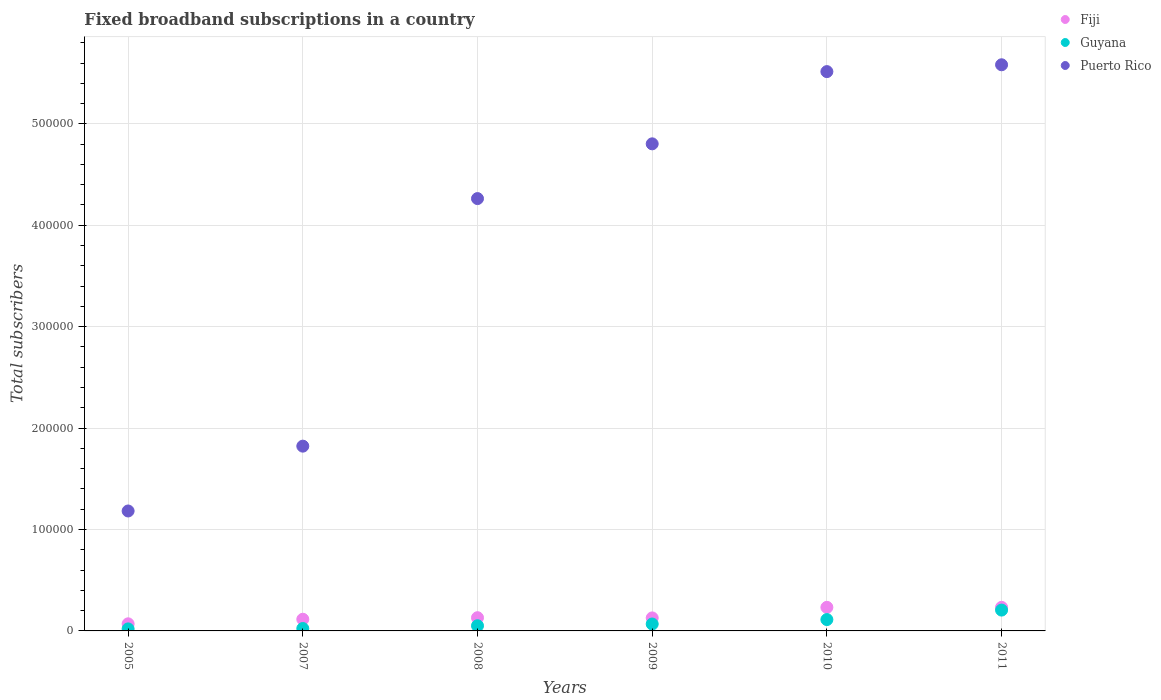How many different coloured dotlines are there?
Provide a short and direct response. 3. What is the number of broadband subscriptions in Fiji in 2005?
Offer a very short reply. 7000. Across all years, what is the maximum number of broadband subscriptions in Puerto Rico?
Your answer should be compact. 5.58e+05. Across all years, what is the minimum number of broadband subscriptions in Puerto Rico?
Your response must be concise. 1.18e+05. In which year was the number of broadband subscriptions in Puerto Rico minimum?
Make the answer very short. 2005. What is the total number of broadband subscriptions in Puerto Rico in the graph?
Provide a short and direct response. 2.32e+06. What is the difference between the number of broadband subscriptions in Guyana in 2008 and that in 2010?
Keep it short and to the point. -6109. What is the difference between the number of broadband subscriptions in Puerto Rico in 2009 and the number of broadband subscriptions in Guyana in 2010?
Make the answer very short. 4.69e+05. What is the average number of broadband subscriptions in Fiji per year?
Your answer should be very brief. 1.51e+04. In the year 2007, what is the difference between the number of broadband subscriptions in Guyana and number of broadband subscriptions in Fiji?
Your response must be concise. -9138. In how many years, is the number of broadband subscriptions in Guyana greater than 480000?
Offer a very short reply. 0. What is the ratio of the number of broadband subscriptions in Puerto Rico in 2008 to that in 2010?
Give a very brief answer. 0.77. Is the difference between the number of broadband subscriptions in Guyana in 2005 and 2008 greater than the difference between the number of broadband subscriptions in Fiji in 2005 and 2008?
Provide a succinct answer. Yes. What is the difference between the highest and the second highest number of broadband subscriptions in Puerto Rico?
Offer a terse response. 6731. What is the difference between the highest and the lowest number of broadband subscriptions in Guyana?
Make the answer very short. 1.85e+04. In how many years, is the number of broadband subscriptions in Puerto Rico greater than the average number of broadband subscriptions in Puerto Rico taken over all years?
Give a very brief answer. 4. Does the number of broadband subscriptions in Fiji monotonically increase over the years?
Keep it short and to the point. No. Is the number of broadband subscriptions in Puerto Rico strictly less than the number of broadband subscriptions in Fiji over the years?
Make the answer very short. No. What is the difference between two consecutive major ticks on the Y-axis?
Make the answer very short. 1.00e+05. Are the values on the major ticks of Y-axis written in scientific E-notation?
Give a very brief answer. No. How are the legend labels stacked?
Your answer should be compact. Vertical. What is the title of the graph?
Offer a very short reply. Fixed broadband subscriptions in a country. Does "Georgia" appear as one of the legend labels in the graph?
Your answer should be compact. No. What is the label or title of the X-axis?
Offer a terse response. Years. What is the label or title of the Y-axis?
Provide a short and direct response. Total subscribers. What is the Total subscribers in Fiji in 2005?
Ensure brevity in your answer.  7000. What is the Total subscribers in Puerto Rico in 2005?
Provide a succinct answer. 1.18e+05. What is the Total subscribers of Fiji in 2007?
Your answer should be compact. 1.15e+04. What is the Total subscribers of Guyana in 2007?
Your answer should be compact. 2362. What is the Total subscribers in Puerto Rico in 2007?
Your answer should be compact. 1.82e+05. What is the Total subscribers of Fiji in 2008?
Keep it short and to the point. 1.30e+04. What is the Total subscribers of Guyana in 2008?
Provide a short and direct response. 5084. What is the Total subscribers in Puerto Rico in 2008?
Make the answer very short. 4.26e+05. What is the Total subscribers of Fiji in 2009?
Your answer should be very brief. 1.28e+04. What is the Total subscribers in Guyana in 2009?
Give a very brief answer. 6823. What is the Total subscribers in Puerto Rico in 2009?
Provide a short and direct response. 4.80e+05. What is the Total subscribers of Fiji in 2010?
Offer a very short reply. 2.32e+04. What is the Total subscribers in Guyana in 2010?
Your response must be concise. 1.12e+04. What is the Total subscribers in Puerto Rico in 2010?
Ensure brevity in your answer.  5.52e+05. What is the Total subscribers of Fiji in 2011?
Your response must be concise. 2.32e+04. What is the Total subscribers in Guyana in 2011?
Give a very brief answer. 2.05e+04. What is the Total subscribers in Puerto Rico in 2011?
Your response must be concise. 5.58e+05. Across all years, what is the maximum Total subscribers of Fiji?
Ensure brevity in your answer.  2.32e+04. Across all years, what is the maximum Total subscribers in Guyana?
Keep it short and to the point. 2.05e+04. Across all years, what is the maximum Total subscribers of Puerto Rico?
Offer a terse response. 5.58e+05. Across all years, what is the minimum Total subscribers in Fiji?
Your response must be concise. 7000. Across all years, what is the minimum Total subscribers in Guyana?
Your answer should be compact. 2000. Across all years, what is the minimum Total subscribers of Puerto Rico?
Your answer should be compact. 1.18e+05. What is the total Total subscribers in Fiji in the graph?
Your answer should be compact. 9.09e+04. What is the total Total subscribers in Guyana in the graph?
Provide a succinct answer. 4.80e+04. What is the total Total subscribers of Puerto Rico in the graph?
Provide a short and direct response. 2.32e+06. What is the difference between the Total subscribers of Fiji in 2005 and that in 2007?
Ensure brevity in your answer.  -4500. What is the difference between the Total subscribers of Guyana in 2005 and that in 2007?
Provide a succinct answer. -362. What is the difference between the Total subscribers in Puerto Rico in 2005 and that in 2007?
Give a very brief answer. -6.39e+04. What is the difference between the Total subscribers of Fiji in 2005 and that in 2008?
Ensure brevity in your answer.  -6031. What is the difference between the Total subscribers of Guyana in 2005 and that in 2008?
Your answer should be very brief. -3084. What is the difference between the Total subscribers in Puerto Rico in 2005 and that in 2008?
Offer a very short reply. -3.08e+05. What is the difference between the Total subscribers of Fiji in 2005 and that in 2009?
Your response must be concise. -5830. What is the difference between the Total subscribers of Guyana in 2005 and that in 2009?
Your answer should be very brief. -4823. What is the difference between the Total subscribers in Puerto Rico in 2005 and that in 2009?
Keep it short and to the point. -3.62e+05. What is the difference between the Total subscribers in Fiji in 2005 and that in 2010?
Keep it short and to the point. -1.62e+04. What is the difference between the Total subscribers in Guyana in 2005 and that in 2010?
Provide a short and direct response. -9193. What is the difference between the Total subscribers of Puerto Rico in 2005 and that in 2010?
Give a very brief answer. -4.33e+05. What is the difference between the Total subscribers in Fiji in 2005 and that in 2011?
Ensure brevity in your answer.  -1.62e+04. What is the difference between the Total subscribers of Guyana in 2005 and that in 2011?
Provide a short and direct response. -1.85e+04. What is the difference between the Total subscribers of Puerto Rico in 2005 and that in 2011?
Your answer should be compact. -4.40e+05. What is the difference between the Total subscribers in Fiji in 2007 and that in 2008?
Offer a terse response. -1531. What is the difference between the Total subscribers in Guyana in 2007 and that in 2008?
Your answer should be very brief. -2722. What is the difference between the Total subscribers of Puerto Rico in 2007 and that in 2008?
Give a very brief answer. -2.44e+05. What is the difference between the Total subscribers in Fiji in 2007 and that in 2009?
Provide a short and direct response. -1330. What is the difference between the Total subscribers in Guyana in 2007 and that in 2009?
Provide a short and direct response. -4461. What is the difference between the Total subscribers of Puerto Rico in 2007 and that in 2009?
Offer a very short reply. -2.98e+05. What is the difference between the Total subscribers of Fiji in 2007 and that in 2010?
Offer a terse response. -1.18e+04. What is the difference between the Total subscribers in Guyana in 2007 and that in 2010?
Offer a terse response. -8831. What is the difference between the Total subscribers of Puerto Rico in 2007 and that in 2010?
Your answer should be compact. -3.69e+05. What is the difference between the Total subscribers in Fiji in 2007 and that in 2011?
Your answer should be compact. -1.18e+04. What is the difference between the Total subscribers in Guyana in 2007 and that in 2011?
Keep it short and to the point. -1.82e+04. What is the difference between the Total subscribers in Puerto Rico in 2007 and that in 2011?
Provide a succinct answer. -3.76e+05. What is the difference between the Total subscribers in Fiji in 2008 and that in 2009?
Make the answer very short. 201. What is the difference between the Total subscribers in Guyana in 2008 and that in 2009?
Keep it short and to the point. -1739. What is the difference between the Total subscribers in Puerto Rico in 2008 and that in 2009?
Ensure brevity in your answer.  -5.40e+04. What is the difference between the Total subscribers in Fiji in 2008 and that in 2010?
Give a very brief answer. -1.02e+04. What is the difference between the Total subscribers in Guyana in 2008 and that in 2010?
Give a very brief answer. -6109. What is the difference between the Total subscribers in Puerto Rico in 2008 and that in 2010?
Ensure brevity in your answer.  -1.25e+05. What is the difference between the Total subscribers of Fiji in 2008 and that in 2011?
Make the answer very short. -1.02e+04. What is the difference between the Total subscribers of Guyana in 2008 and that in 2011?
Make the answer very short. -1.55e+04. What is the difference between the Total subscribers of Puerto Rico in 2008 and that in 2011?
Provide a short and direct response. -1.32e+05. What is the difference between the Total subscribers of Fiji in 2009 and that in 2010?
Offer a very short reply. -1.04e+04. What is the difference between the Total subscribers in Guyana in 2009 and that in 2010?
Provide a succinct answer. -4370. What is the difference between the Total subscribers in Puerto Rico in 2009 and that in 2010?
Ensure brevity in your answer.  -7.12e+04. What is the difference between the Total subscribers in Fiji in 2009 and that in 2011?
Ensure brevity in your answer.  -1.04e+04. What is the difference between the Total subscribers of Guyana in 2009 and that in 2011?
Give a very brief answer. -1.37e+04. What is the difference between the Total subscribers of Puerto Rico in 2009 and that in 2011?
Your answer should be compact. -7.80e+04. What is the difference between the Total subscribers in Fiji in 2010 and that in 2011?
Give a very brief answer. 0. What is the difference between the Total subscribers in Guyana in 2010 and that in 2011?
Offer a terse response. -9347. What is the difference between the Total subscribers of Puerto Rico in 2010 and that in 2011?
Ensure brevity in your answer.  -6731. What is the difference between the Total subscribers in Fiji in 2005 and the Total subscribers in Guyana in 2007?
Your answer should be compact. 4638. What is the difference between the Total subscribers in Fiji in 2005 and the Total subscribers in Puerto Rico in 2007?
Keep it short and to the point. -1.75e+05. What is the difference between the Total subscribers in Guyana in 2005 and the Total subscribers in Puerto Rico in 2007?
Your answer should be very brief. -1.80e+05. What is the difference between the Total subscribers in Fiji in 2005 and the Total subscribers in Guyana in 2008?
Provide a short and direct response. 1916. What is the difference between the Total subscribers of Fiji in 2005 and the Total subscribers of Puerto Rico in 2008?
Ensure brevity in your answer.  -4.19e+05. What is the difference between the Total subscribers in Guyana in 2005 and the Total subscribers in Puerto Rico in 2008?
Your answer should be compact. -4.24e+05. What is the difference between the Total subscribers in Fiji in 2005 and the Total subscribers in Guyana in 2009?
Provide a succinct answer. 177. What is the difference between the Total subscribers of Fiji in 2005 and the Total subscribers of Puerto Rico in 2009?
Provide a succinct answer. -4.73e+05. What is the difference between the Total subscribers of Guyana in 2005 and the Total subscribers of Puerto Rico in 2009?
Ensure brevity in your answer.  -4.78e+05. What is the difference between the Total subscribers in Fiji in 2005 and the Total subscribers in Guyana in 2010?
Your response must be concise. -4193. What is the difference between the Total subscribers of Fiji in 2005 and the Total subscribers of Puerto Rico in 2010?
Your answer should be compact. -5.45e+05. What is the difference between the Total subscribers in Guyana in 2005 and the Total subscribers in Puerto Rico in 2010?
Your answer should be compact. -5.50e+05. What is the difference between the Total subscribers of Fiji in 2005 and the Total subscribers of Guyana in 2011?
Keep it short and to the point. -1.35e+04. What is the difference between the Total subscribers of Fiji in 2005 and the Total subscribers of Puerto Rico in 2011?
Provide a succinct answer. -5.51e+05. What is the difference between the Total subscribers in Guyana in 2005 and the Total subscribers in Puerto Rico in 2011?
Provide a short and direct response. -5.56e+05. What is the difference between the Total subscribers in Fiji in 2007 and the Total subscribers in Guyana in 2008?
Ensure brevity in your answer.  6416. What is the difference between the Total subscribers of Fiji in 2007 and the Total subscribers of Puerto Rico in 2008?
Your answer should be compact. -4.15e+05. What is the difference between the Total subscribers of Guyana in 2007 and the Total subscribers of Puerto Rico in 2008?
Provide a succinct answer. -4.24e+05. What is the difference between the Total subscribers of Fiji in 2007 and the Total subscribers of Guyana in 2009?
Your answer should be compact. 4677. What is the difference between the Total subscribers of Fiji in 2007 and the Total subscribers of Puerto Rico in 2009?
Keep it short and to the point. -4.69e+05. What is the difference between the Total subscribers in Guyana in 2007 and the Total subscribers in Puerto Rico in 2009?
Offer a terse response. -4.78e+05. What is the difference between the Total subscribers of Fiji in 2007 and the Total subscribers of Guyana in 2010?
Offer a terse response. 307. What is the difference between the Total subscribers in Fiji in 2007 and the Total subscribers in Puerto Rico in 2010?
Provide a succinct answer. -5.40e+05. What is the difference between the Total subscribers in Guyana in 2007 and the Total subscribers in Puerto Rico in 2010?
Make the answer very short. -5.49e+05. What is the difference between the Total subscribers in Fiji in 2007 and the Total subscribers in Guyana in 2011?
Offer a very short reply. -9040. What is the difference between the Total subscribers in Fiji in 2007 and the Total subscribers in Puerto Rico in 2011?
Keep it short and to the point. -5.47e+05. What is the difference between the Total subscribers of Guyana in 2007 and the Total subscribers of Puerto Rico in 2011?
Provide a short and direct response. -5.56e+05. What is the difference between the Total subscribers in Fiji in 2008 and the Total subscribers in Guyana in 2009?
Your answer should be very brief. 6208. What is the difference between the Total subscribers of Fiji in 2008 and the Total subscribers of Puerto Rico in 2009?
Make the answer very short. -4.67e+05. What is the difference between the Total subscribers in Guyana in 2008 and the Total subscribers in Puerto Rico in 2009?
Provide a succinct answer. -4.75e+05. What is the difference between the Total subscribers in Fiji in 2008 and the Total subscribers in Guyana in 2010?
Provide a succinct answer. 1838. What is the difference between the Total subscribers in Fiji in 2008 and the Total subscribers in Puerto Rico in 2010?
Ensure brevity in your answer.  -5.38e+05. What is the difference between the Total subscribers of Guyana in 2008 and the Total subscribers of Puerto Rico in 2010?
Make the answer very short. -5.46e+05. What is the difference between the Total subscribers of Fiji in 2008 and the Total subscribers of Guyana in 2011?
Make the answer very short. -7509. What is the difference between the Total subscribers in Fiji in 2008 and the Total subscribers in Puerto Rico in 2011?
Offer a terse response. -5.45e+05. What is the difference between the Total subscribers in Guyana in 2008 and the Total subscribers in Puerto Rico in 2011?
Keep it short and to the point. -5.53e+05. What is the difference between the Total subscribers in Fiji in 2009 and the Total subscribers in Guyana in 2010?
Your response must be concise. 1637. What is the difference between the Total subscribers in Fiji in 2009 and the Total subscribers in Puerto Rico in 2010?
Provide a short and direct response. -5.39e+05. What is the difference between the Total subscribers in Guyana in 2009 and the Total subscribers in Puerto Rico in 2010?
Keep it short and to the point. -5.45e+05. What is the difference between the Total subscribers of Fiji in 2009 and the Total subscribers of Guyana in 2011?
Offer a very short reply. -7710. What is the difference between the Total subscribers in Fiji in 2009 and the Total subscribers in Puerto Rico in 2011?
Your answer should be compact. -5.45e+05. What is the difference between the Total subscribers in Guyana in 2009 and the Total subscribers in Puerto Rico in 2011?
Give a very brief answer. -5.51e+05. What is the difference between the Total subscribers of Fiji in 2010 and the Total subscribers of Guyana in 2011?
Keep it short and to the point. 2710. What is the difference between the Total subscribers of Fiji in 2010 and the Total subscribers of Puerto Rico in 2011?
Make the answer very short. -5.35e+05. What is the difference between the Total subscribers in Guyana in 2010 and the Total subscribers in Puerto Rico in 2011?
Your answer should be compact. -5.47e+05. What is the average Total subscribers of Fiji per year?
Ensure brevity in your answer.  1.51e+04. What is the average Total subscribers of Guyana per year?
Your answer should be compact. 8000.33. What is the average Total subscribers of Puerto Rico per year?
Provide a succinct answer. 3.86e+05. In the year 2005, what is the difference between the Total subscribers in Fiji and Total subscribers in Guyana?
Offer a very short reply. 5000. In the year 2005, what is the difference between the Total subscribers in Fiji and Total subscribers in Puerto Rico?
Your answer should be very brief. -1.11e+05. In the year 2005, what is the difference between the Total subscribers in Guyana and Total subscribers in Puerto Rico?
Ensure brevity in your answer.  -1.16e+05. In the year 2007, what is the difference between the Total subscribers of Fiji and Total subscribers of Guyana?
Give a very brief answer. 9138. In the year 2007, what is the difference between the Total subscribers in Fiji and Total subscribers in Puerto Rico?
Give a very brief answer. -1.71e+05. In the year 2007, what is the difference between the Total subscribers of Guyana and Total subscribers of Puerto Rico?
Your answer should be compact. -1.80e+05. In the year 2008, what is the difference between the Total subscribers in Fiji and Total subscribers in Guyana?
Ensure brevity in your answer.  7947. In the year 2008, what is the difference between the Total subscribers in Fiji and Total subscribers in Puerto Rico?
Give a very brief answer. -4.13e+05. In the year 2008, what is the difference between the Total subscribers in Guyana and Total subscribers in Puerto Rico?
Offer a very short reply. -4.21e+05. In the year 2009, what is the difference between the Total subscribers of Fiji and Total subscribers of Guyana?
Provide a succinct answer. 6007. In the year 2009, what is the difference between the Total subscribers in Fiji and Total subscribers in Puerto Rico?
Ensure brevity in your answer.  -4.67e+05. In the year 2009, what is the difference between the Total subscribers in Guyana and Total subscribers in Puerto Rico?
Make the answer very short. -4.73e+05. In the year 2010, what is the difference between the Total subscribers in Fiji and Total subscribers in Guyana?
Provide a short and direct response. 1.21e+04. In the year 2010, what is the difference between the Total subscribers of Fiji and Total subscribers of Puerto Rico?
Ensure brevity in your answer.  -5.28e+05. In the year 2010, what is the difference between the Total subscribers of Guyana and Total subscribers of Puerto Rico?
Your response must be concise. -5.40e+05. In the year 2011, what is the difference between the Total subscribers of Fiji and Total subscribers of Guyana?
Give a very brief answer. 2710. In the year 2011, what is the difference between the Total subscribers of Fiji and Total subscribers of Puerto Rico?
Ensure brevity in your answer.  -5.35e+05. In the year 2011, what is the difference between the Total subscribers of Guyana and Total subscribers of Puerto Rico?
Provide a short and direct response. -5.38e+05. What is the ratio of the Total subscribers in Fiji in 2005 to that in 2007?
Your answer should be compact. 0.61. What is the ratio of the Total subscribers of Guyana in 2005 to that in 2007?
Make the answer very short. 0.85. What is the ratio of the Total subscribers of Puerto Rico in 2005 to that in 2007?
Keep it short and to the point. 0.65. What is the ratio of the Total subscribers in Fiji in 2005 to that in 2008?
Give a very brief answer. 0.54. What is the ratio of the Total subscribers of Guyana in 2005 to that in 2008?
Keep it short and to the point. 0.39. What is the ratio of the Total subscribers of Puerto Rico in 2005 to that in 2008?
Offer a terse response. 0.28. What is the ratio of the Total subscribers in Fiji in 2005 to that in 2009?
Offer a very short reply. 0.55. What is the ratio of the Total subscribers of Guyana in 2005 to that in 2009?
Give a very brief answer. 0.29. What is the ratio of the Total subscribers of Puerto Rico in 2005 to that in 2009?
Provide a succinct answer. 0.25. What is the ratio of the Total subscribers in Fiji in 2005 to that in 2010?
Keep it short and to the point. 0.3. What is the ratio of the Total subscribers in Guyana in 2005 to that in 2010?
Give a very brief answer. 0.18. What is the ratio of the Total subscribers of Puerto Rico in 2005 to that in 2010?
Offer a very short reply. 0.21. What is the ratio of the Total subscribers in Fiji in 2005 to that in 2011?
Offer a terse response. 0.3. What is the ratio of the Total subscribers in Guyana in 2005 to that in 2011?
Offer a very short reply. 0.1. What is the ratio of the Total subscribers of Puerto Rico in 2005 to that in 2011?
Your response must be concise. 0.21. What is the ratio of the Total subscribers of Fiji in 2007 to that in 2008?
Your answer should be compact. 0.88. What is the ratio of the Total subscribers of Guyana in 2007 to that in 2008?
Your response must be concise. 0.46. What is the ratio of the Total subscribers in Puerto Rico in 2007 to that in 2008?
Your answer should be very brief. 0.43. What is the ratio of the Total subscribers in Fiji in 2007 to that in 2009?
Offer a very short reply. 0.9. What is the ratio of the Total subscribers of Guyana in 2007 to that in 2009?
Your response must be concise. 0.35. What is the ratio of the Total subscribers of Puerto Rico in 2007 to that in 2009?
Give a very brief answer. 0.38. What is the ratio of the Total subscribers in Fiji in 2007 to that in 2010?
Your answer should be very brief. 0.49. What is the ratio of the Total subscribers of Guyana in 2007 to that in 2010?
Your answer should be compact. 0.21. What is the ratio of the Total subscribers of Puerto Rico in 2007 to that in 2010?
Your response must be concise. 0.33. What is the ratio of the Total subscribers of Fiji in 2007 to that in 2011?
Your answer should be very brief. 0.49. What is the ratio of the Total subscribers in Guyana in 2007 to that in 2011?
Offer a very short reply. 0.12. What is the ratio of the Total subscribers in Puerto Rico in 2007 to that in 2011?
Offer a very short reply. 0.33. What is the ratio of the Total subscribers in Fiji in 2008 to that in 2009?
Your answer should be compact. 1.02. What is the ratio of the Total subscribers in Guyana in 2008 to that in 2009?
Your response must be concise. 0.75. What is the ratio of the Total subscribers in Puerto Rico in 2008 to that in 2009?
Make the answer very short. 0.89. What is the ratio of the Total subscribers of Fiji in 2008 to that in 2010?
Make the answer very short. 0.56. What is the ratio of the Total subscribers of Guyana in 2008 to that in 2010?
Keep it short and to the point. 0.45. What is the ratio of the Total subscribers in Puerto Rico in 2008 to that in 2010?
Ensure brevity in your answer.  0.77. What is the ratio of the Total subscribers of Fiji in 2008 to that in 2011?
Make the answer very short. 0.56. What is the ratio of the Total subscribers in Guyana in 2008 to that in 2011?
Provide a succinct answer. 0.25. What is the ratio of the Total subscribers in Puerto Rico in 2008 to that in 2011?
Offer a terse response. 0.76. What is the ratio of the Total subscribers of Fiji in 2009 to that in 2010?
Keep it short and to the point. 0.55. What is the ratio of the Total subscribers of Guyana in 2009 to that in 2010?
Keep it short and to the point. 0.61. What is the ratio of the Total subscribers of Puerto Rico in 2009 to that in 2010?
Offer a terse response. 0.87. What is the ratio of the Total subscribers in Fiji in 2009 to that in 2011?
Provide a succinct answer. 0.55. What is the ratio of the Total subscribers in Guyana in 2009 to that in 2011?
Your answer should be very brief. 0.33. What is the ratio of the Total subscribers of Puerto Rico in 2009 to that in 2011?
Provide a short and direct response. 0.86. What is the ratio of the Total subscribers in Fiji in 2010 to that in 2011?
Ensure brevity in your answer.  1. What is the ratio of the Total subscribers in Guyana in 2010 to that in 2011?
Ensure brevity in your answer.  0.54. What is the ratio of the Total subscribers of Puerto Rico in 2010 to that in 2011?
Offer a terse response. 0.99. What is the difference between the highest and the second highest Total subscribers of Fiji?
Offer a terse response. 0. What is the difference between the highest and the second highest Total subscribers of Guyana?
Keep it short and to the point. 9347. What is the difference between the highest and the second highest Total subscribers of Puerto Rico?
Your response must be concise. 6731. What is the difference between the highest and the lowest Total subscribers in Fiji?
Make the answer very short. 1.62e+04. What is the difference between the highest and the lowest Total subscribers of Guyana?
Your answer should be very brief. 1.85e+04. What is the difference between the highest and the lowest Total subscribers in Puerto Rico?
Ensure brevity in your answer.  4.40e+05. 